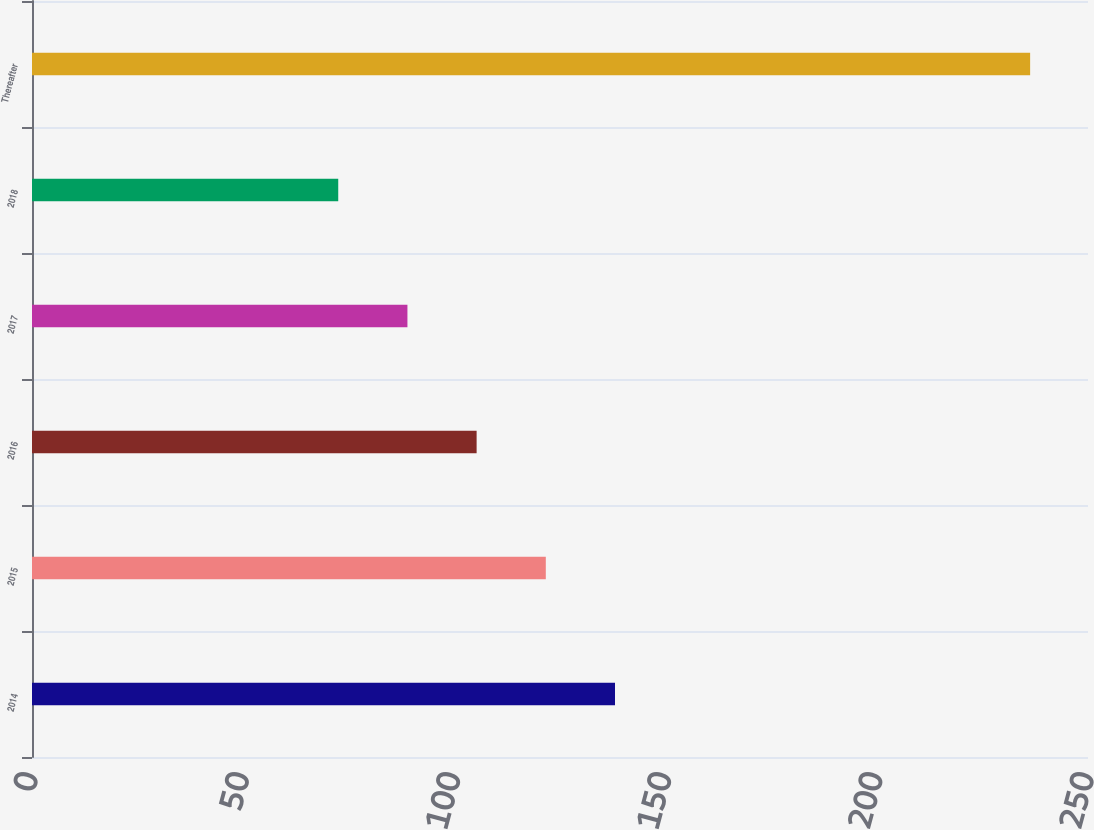Convert chart to OTSL. <chart><loc_0><loc_0><loc_500><loc_500><bar_chart><fcel>2014<fcel>2015<fcel>2016<fcel>2017<fcel>2018<fcel>Thereafter<nl><fcel>138.02<fcel>121.64<fcel>105.26<fcel>88.88<fcel>72.5<fcel>236.3<nl></chart> 